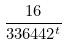Convert formula to latex. <formula><loc_0><loc_0><loc_500><loc_500>\frac { 1 6 } { 3 3 6 4 4 2 ^ { t } }</formula> 